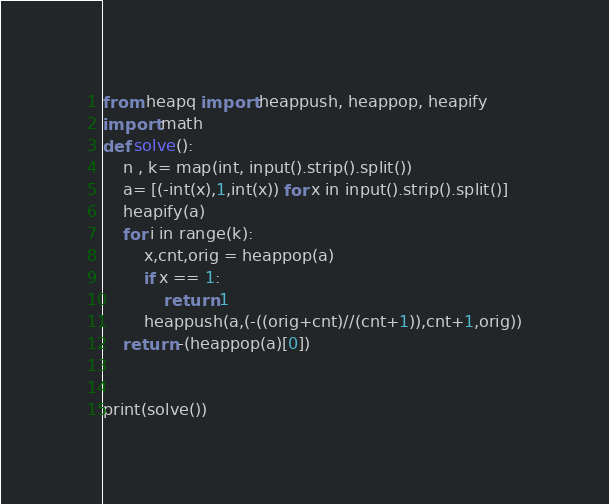Convert code to text. <code><loc_0><loc_0><loc_500><loc_500><_Python_>from heapq import heappush, heappop, heapify
import math
def solve():
	n , k= map(int, input().strip().split())
	a= [(-int(x),1,int(x)) for x in input().strip().split()]
	heapify(a)
	for i in range(k):
		x,cnt,orig = heappop(a)
		if x == 1:
			return 1
		heappush(a,(-((orig+cnt)//(cnt+1)),cnt+1,orig))
	return -(heappop(a)[0])


print(solve())</code> 